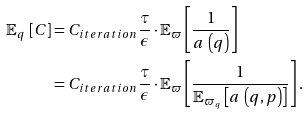<formula> <loc_0><loc_0><loc_500><loc_500>\mathbb { E } _ { q } \, \left [ C \right ] & = C _ { i t e r a t i o n } \frac { \tau } { \epsilon } \cdot \mathbb { E } _ { \varpi } \left [ \frac { 1 } { a \, \left ( q \right ) } \right ] \\ & = C _ { i t e r a t i o n } \frac { \tau } { \epsilon } \cdot \mathbb { E } _ { \varpi } \left [ \frac { 1 } { \mathbb { E } _ { \varpi _ { q } } \left [ a \, \left ( q , p \right ) \right ] } \right ] .</formula> 